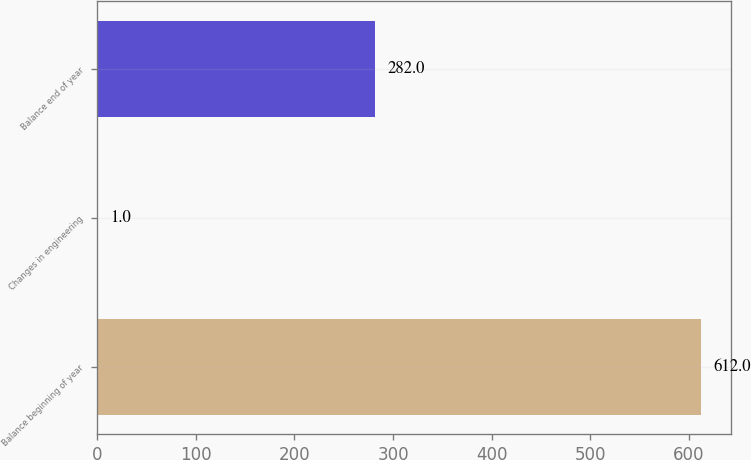Convert chart. <chart><loc_0><loc_0><loc_500><loc_500><bar_chart><fcel>Balance beginning of year<fcel>Changes in engineering<fcel>Balance end of year<nl><fcel>612<fcel>1<fcel>282<nl></chart> 